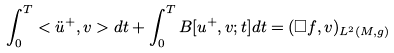<formula> <loc_0><loc_0><loc_500><loc_500>\int ^ { T } _ { 0 } < \ddot { u } ^ { + } , v > d t + \int ^ { T } _ { 0 } B [ u ^ { + } , v ; t ] d t = ( \square f , v ) _ { L ^ { 2 } ( M , { g } ) }</formula> 